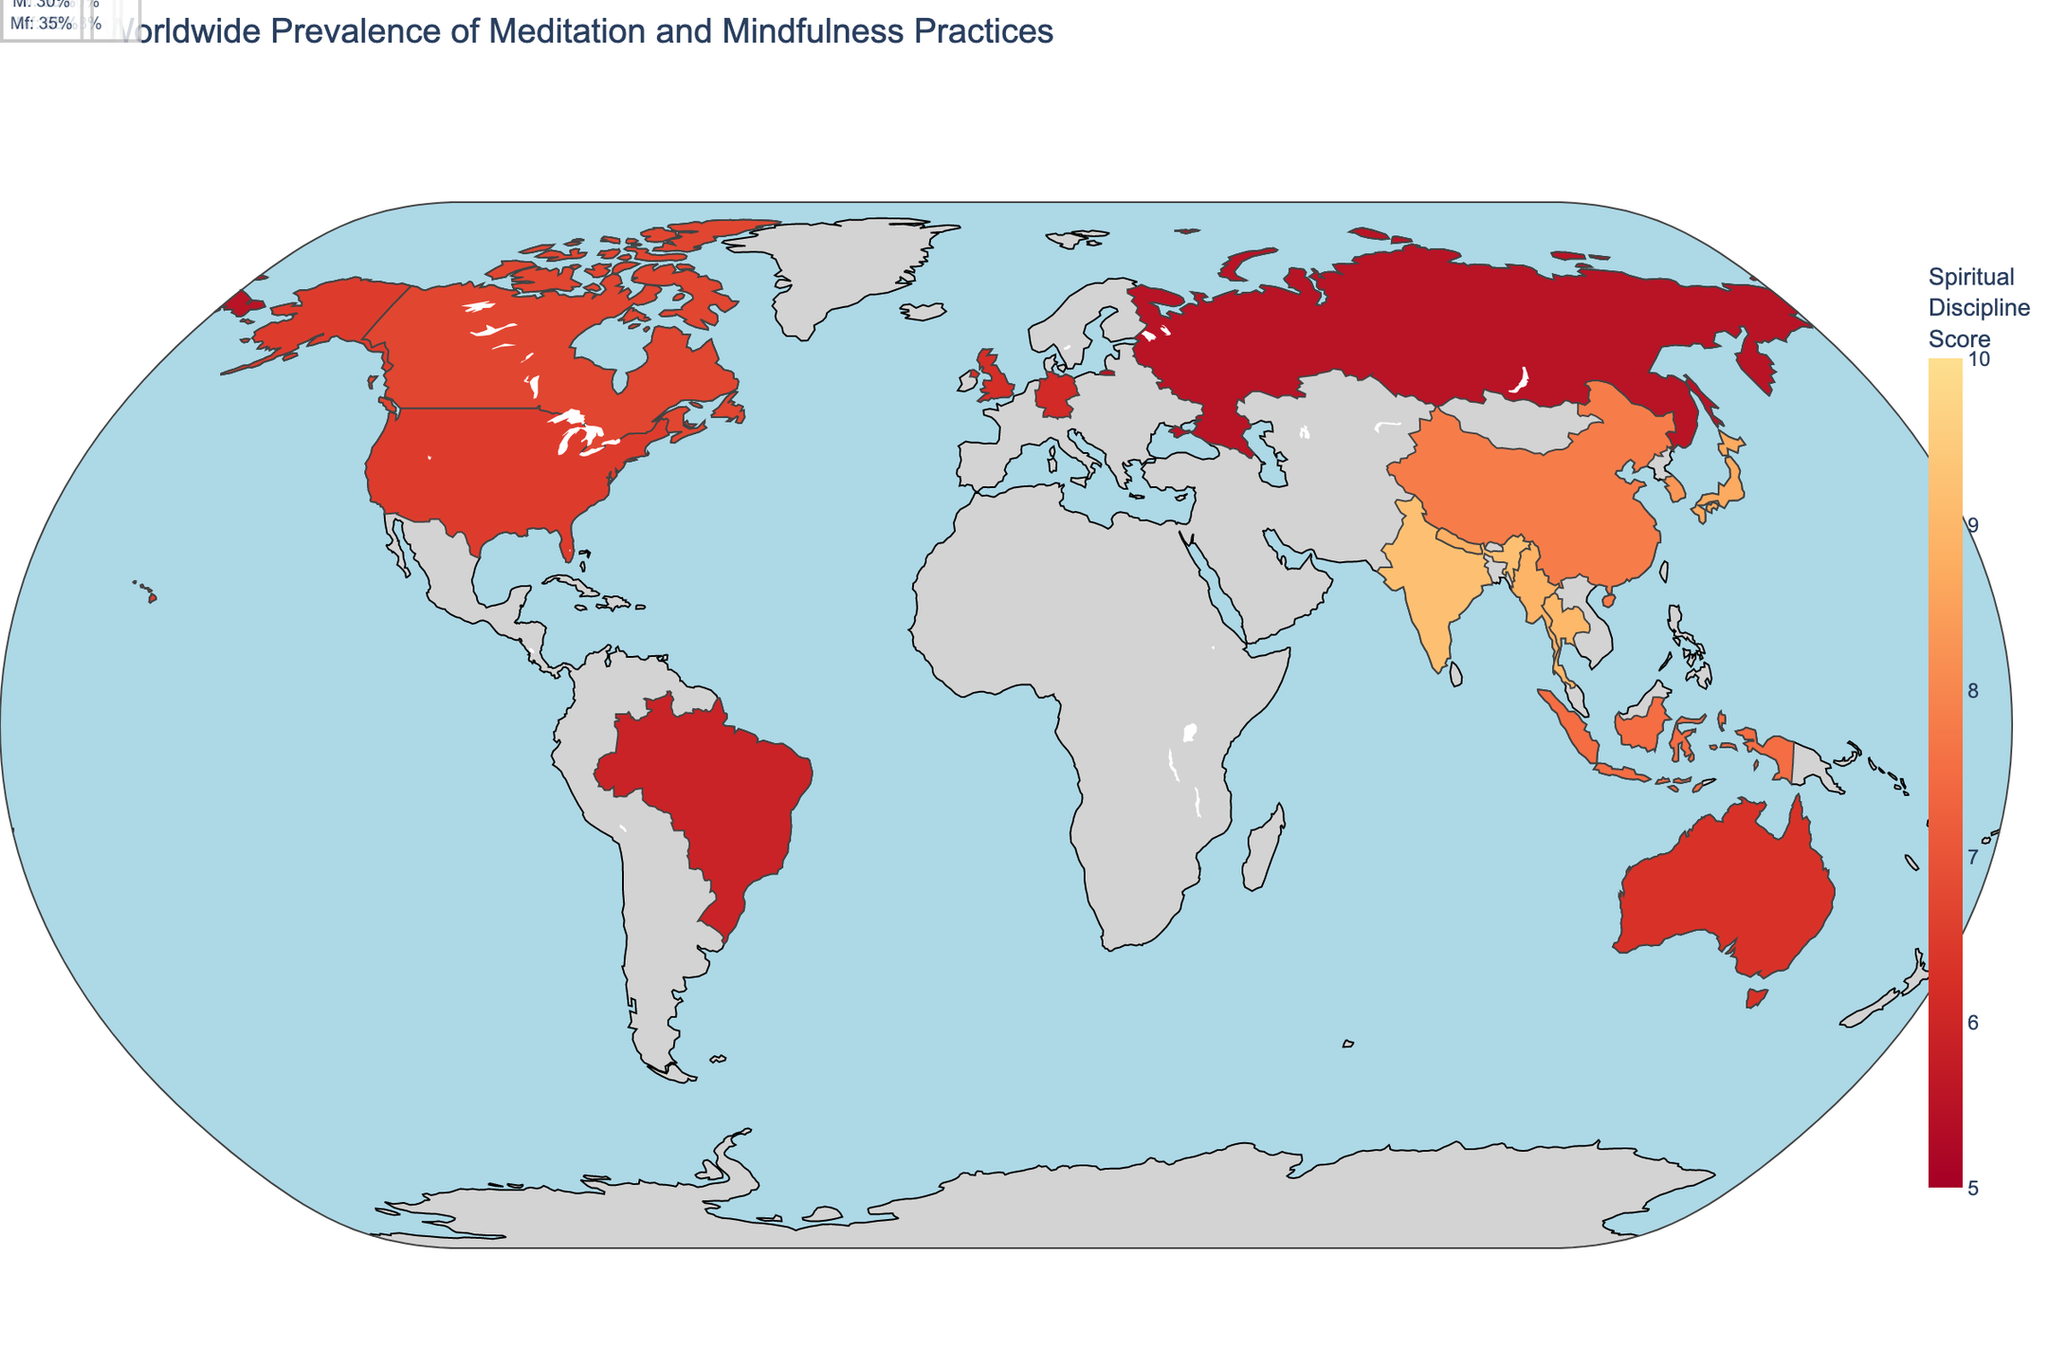What's the country with the highest prevalence of meditation? Look for the country with the highest percentage value in the "Meditation_Prevalence" column on the plot. Thailand shows the highest value of 80%.
Answer: Thailand Which region includes countries with the Spiritual Discipline Score above 9? Identify countries with a Spiritual Discipline Score above 9 and then note their region. India and Thailand, both with scores of 9.2 and 9.0 respectively, are in South Asia and Southeast Asia.
Answer: South Asia and Southeast Asia What is the average Meditation Prevalence in East Asia? Identify the countries in East Asia (Japan, China, South Korea), sum their Meditation Prevalences (65 + 58 + 61 = 184), and divide by the number of countries (3). The average is 184/3 ≈ 61.3%.
Answer: 61.3% Compare the Spiritual Discipline Scores of South Korea and Japan. Which is higher? Look at the Spiritual Discipline Scores of South Korea (8.3) and Japan (8.7) on the plot. Japan has a higher score.
Answer: Japan Which country has the lowest Mindfulness Prevalence in Europe? Look at the European countries on the plot and their Mindfulness Prevalence values. Russia has the lowest value at 35%.
Answer: Russia Which country has a higher Meditation Prevalence: Nepal or India? Check the Meditation Prevalence for Nepal (70%) and India (72%) on the plot. India is higher.
Answer: India What are the Meditation and Mindfulness Prevalence for Myanmar? Locate Myanmar on the plot and look at its Meditation and Mindfulness Prevalence values (75% and 72% respectively).
Answer: Meditation: 75%, Mindfulness: 72% How does the Spiritual Discipline Score of Brazil compare to Canada? Compare the Spiritual Discipline Scores of Brazil (5.9) and Canada (6.7) on the plot. Canada has a higher score.
Answer: Canada What's the combined average of Meditation Prevalence in North America? Identify the North American countries (United States, Canada), sum their Meditation Prevalence (44 + 46 = 90), and divide by the count (2). The average is 90/2 = 45%.
Answer: 45% What is the range of Spiritual Discipline Scores visible on the map? Look at the color bar legend on the map, which indicates the range of Spiritual Discipline Scores, from 5.5 in Russia to 9.2 in India.
Answer: 5.5 to 9.2 